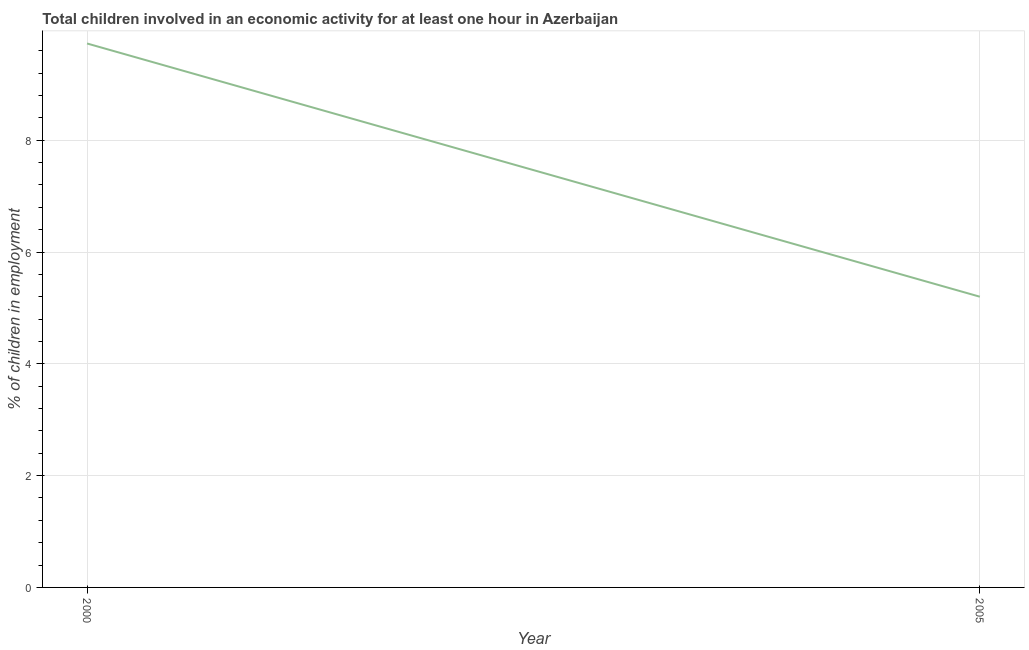What is the percentage of children in employment in 2000?
Your answer should be very brief. 9.73. Across all years, what is the maximum percentage of children in employment?
Ensure brevity in your answer.  9.73. Across all years, what is the minimum percentage of children in employment?
Your answer should be very brief. 5.2. In which year was the percentage of children in employment minimum?
Ensure brevity in your answer.  2005. What is the sum of the percentage of children in employment?
Offer a terse response. 14.93. What is the difference between the percentage of children in employment in 2000 and 2005?
Make the answer very short. 4.53. What is the average percentage of children in employment per year?
Keep it short and to the point. 7.46. What is the median percentage of children in employment?
Your response must be concise. 7.46. In how many years, is the percentage of children in employment greater than 4.8 %?
Provide a short and direct response. 2. What is the ratio of the percentage of children in employment in 2000 to that in 2005?
Offer a very short reply. 1.87. Is the percentage of children in employment in 2000 less than that in 2005?
Ensure brevity in your answer.  No. Does the percentage of children in employment monotonically increase over the years?
Offer a terse response. No. How many lines are there?
Your answer should be very brief. 1. How many years are there in the graph?
Offer a very short reply. 2. What is the difference between two consecutive major ticks on the Y-axis?
Provide a succinct answer. 2. Does the graph contain any zero values?
Keep it short and to the point. No. Does the graph contain grids?
Your answer should be compact. Yes. What is the title of the graph?
Offer a very short reply. Total children involved in an economic activity for at least one hour in Azerbaijan. What is the label or title of the X-axis?
Your response must be concise. Year. What is the label or title of the Y-axis?
Offer a very short reply. % of children in employment. What is the % of children in employment in 2000?
Your answer should be very brief. 9.73. What is the difference between the % of children in employment in 2000 and 2005?
Offer a very short reply. 4.53. What is the ratio of the % of children in employment in 2000 to that in 2005?
Offer a terse response. 1.87. 